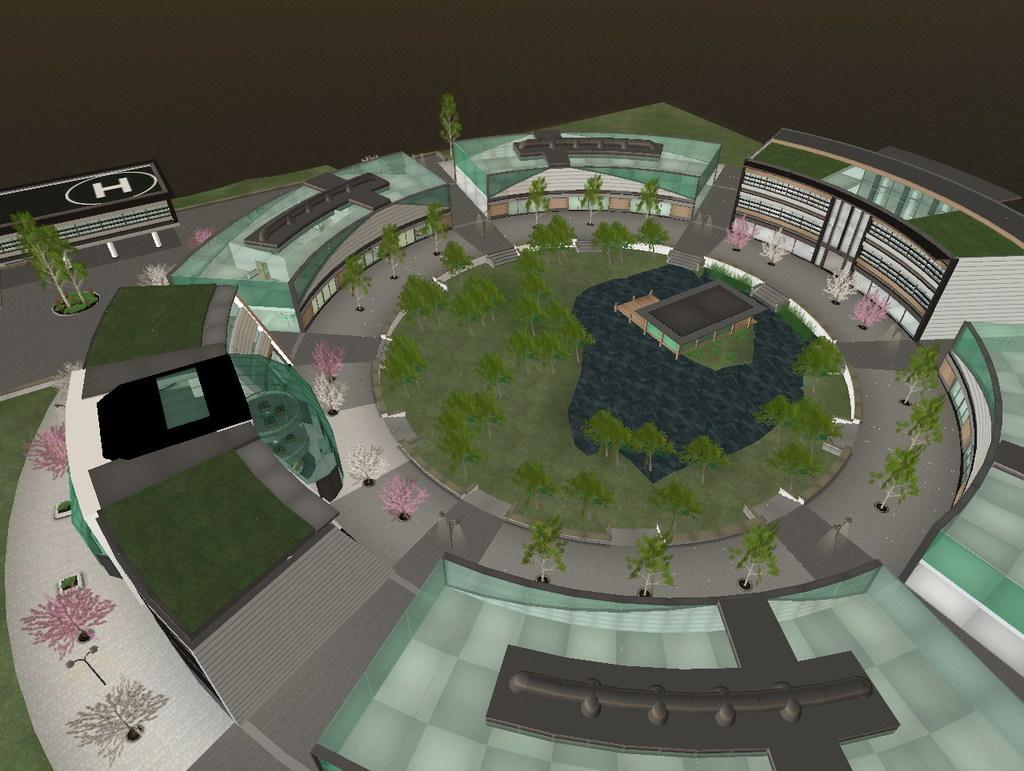What type of image is present in the picture? There is a graphical image in the picture. What structures can be seen in the picture? There are buildings visible in the picture. What type of vegetation is present in the picture? There are trees in the picture. How would you describe the overall lighting in the picture? The background of the image is dark. How many cows are grazing in the picture? There are no cows present in the image; it features a graphical image, buildings, and trees. What type of approval is being given in the picture? There is no indication of any approval process or decision in the image. 